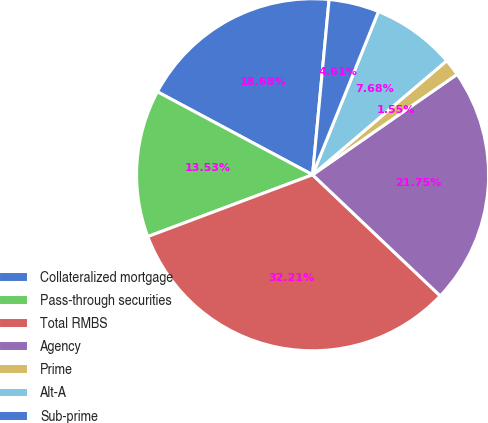Convert chart to OTSL. <chart><loc_0><loc_0><loc_500><loc_500><pie_chart><fcel>Collateralized mortgage<fcel>Pass-through securities<fcel>Total RMBS<fcel>Agency<fcel>Prime<fcel>Alt-A<fcel>Sub-prime<nl><fcel>18.68%<fcel>13.53%<fcel>32.21%<fcel>21.75%<fcel>1.55%<fcel>7.68%<fcel>4.61%<nl></chart> 